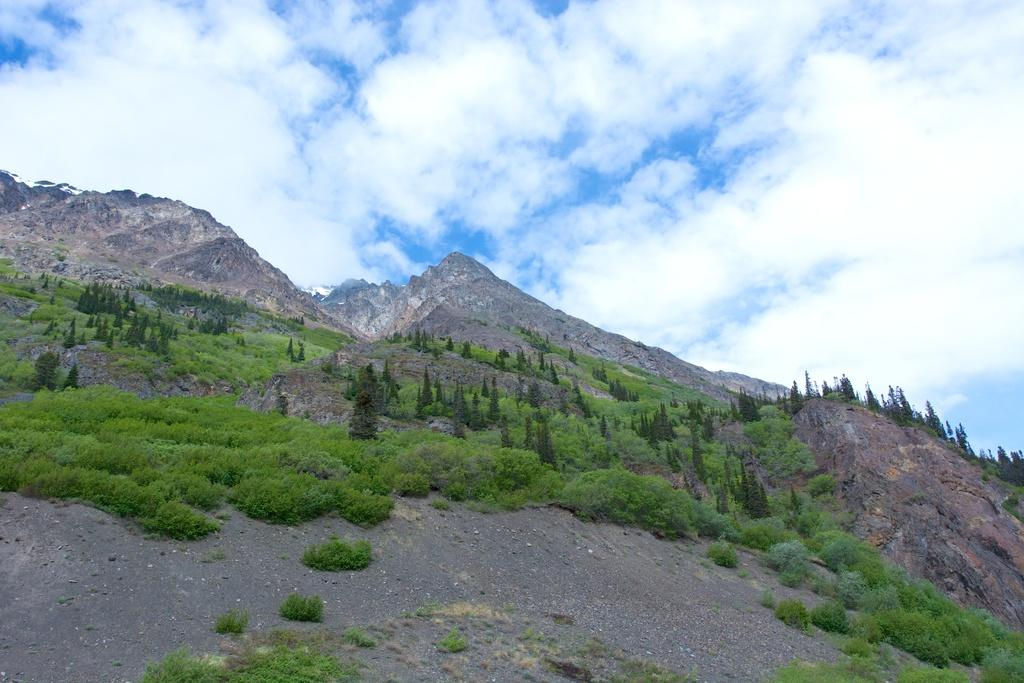What type of natural elements can be seen in the image? There are trees and hills in the image. What is the condition of the sky in the image? The sky is cloudy in the image. How many parcels can be seen being crushed by the trees in the image? There are no parcels present in the image, and therefore no such activity can be observed. What type of bean is growing on the hills in the image? There is no bean plant visible in the image; only trees and hills are present. 